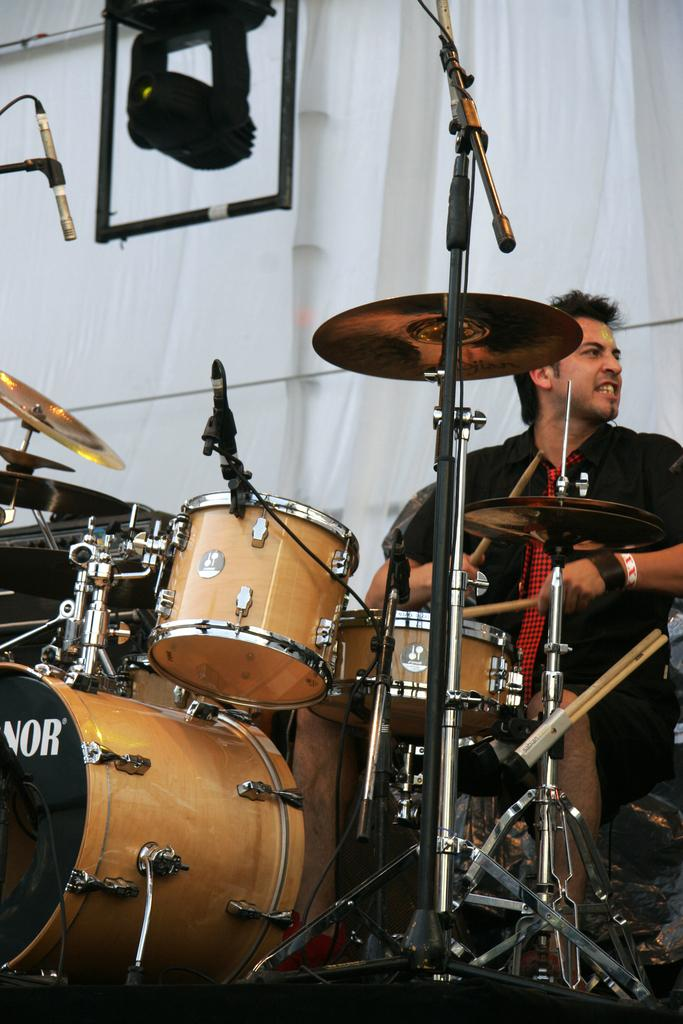What is the main subject of the image? The main subject of the image is a man. What is the man doing in the image? The man is playing musical instruments in the image. Can you describe the background of the image? There is a white curtain and a light in the background of the image. How many babies are visible in the image? There are no babies present in the image. What type of winter clothing is the man wearing in the image? The image does not show the man wearing any winter clothing, as there is no mention of winter or cold weather in the provided facts. 